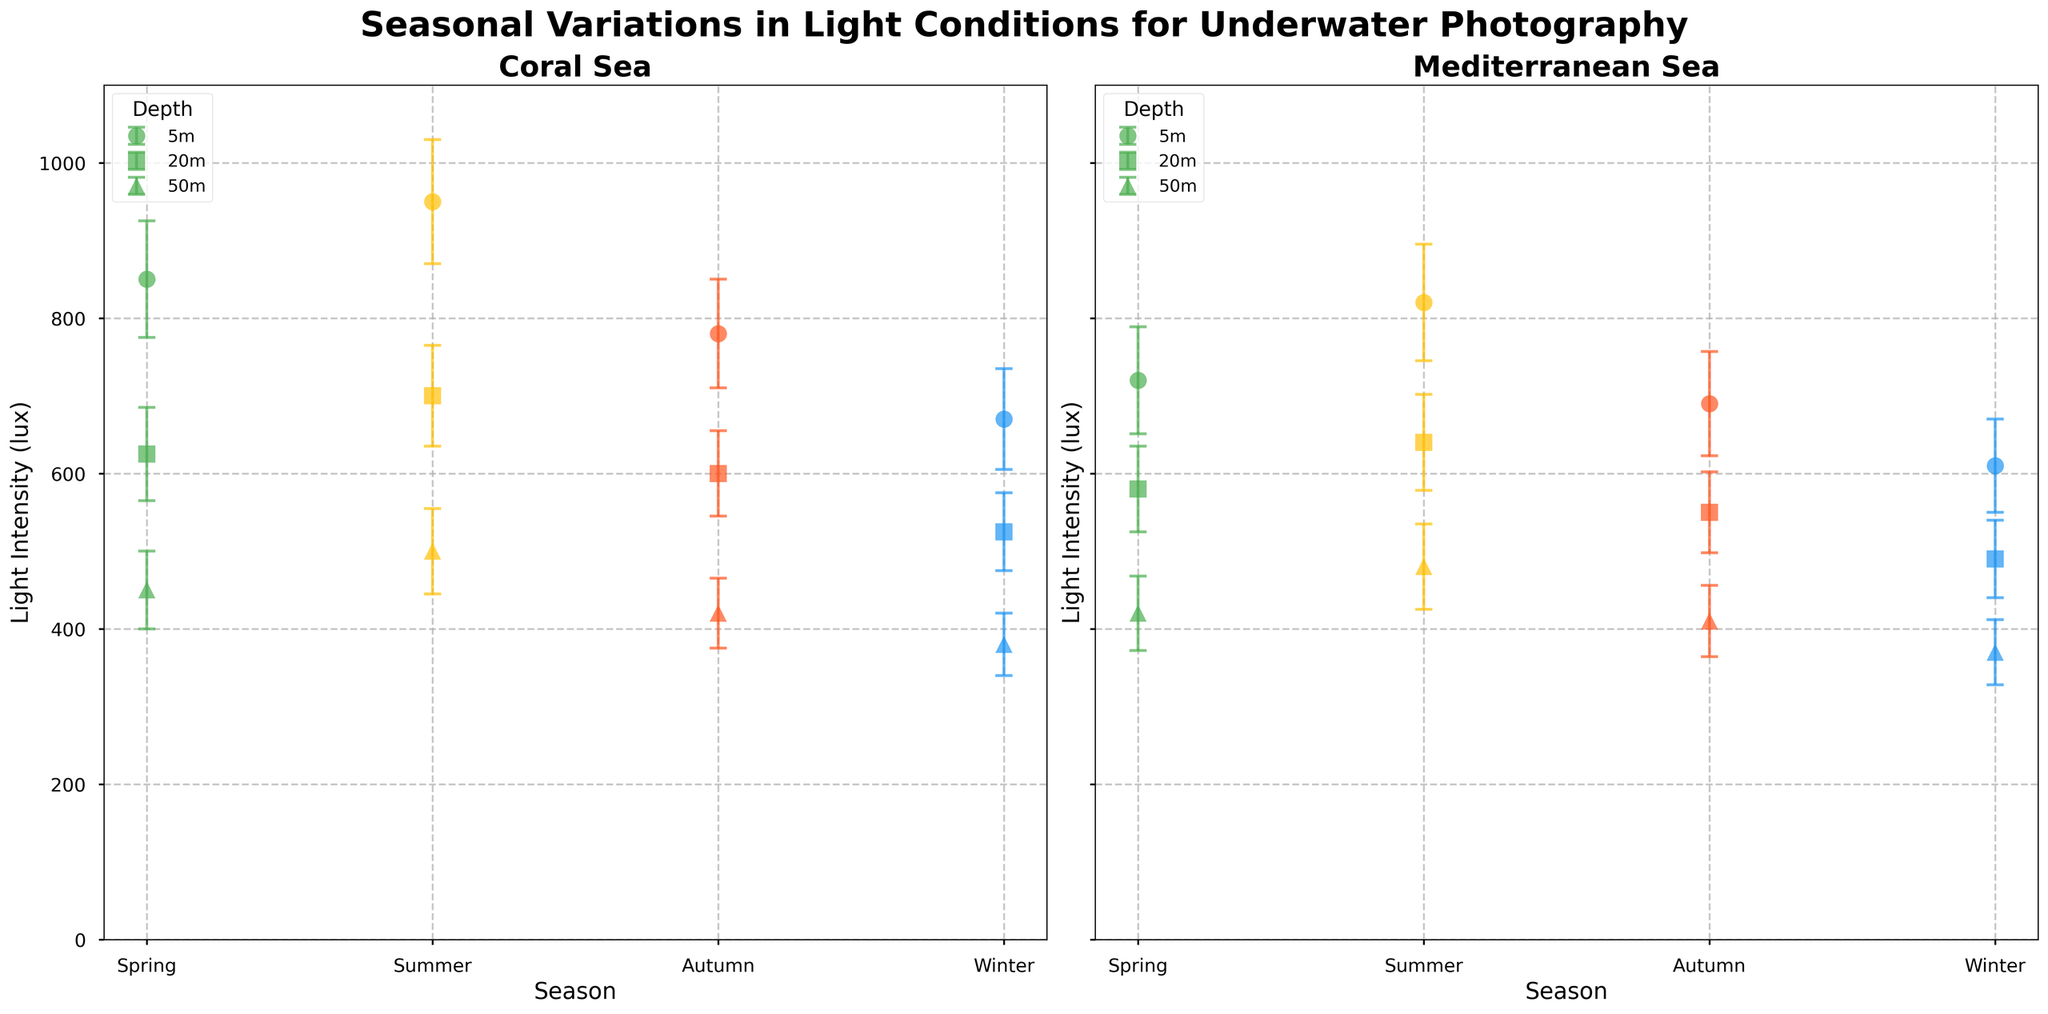What is the title of the figure? The title is displayed prominently at the top of the figure.
Answer: Seasonal Variations in Light Conditions for Underwater Photography Which season has the highest average light intensity at 5 meters depth in the Coral Sea? From the subplot for the Coral Sea, observe the markers at 5 meters depth across seasons. The yellow marker (Summer) is the highest.
Answer: Summer How does the average light intensity at 20 meters in Autumn compare between the Coral Sea and the Mediterranean Sea? Compare the height of markers at 20 meters depth for Autumn in both subplots. The Coral Sea shows higher intensity than the Mediterranean.
Answer: Coral Sea is higher What is the depth with the lowest average light intensity in both locations during Winter? Look at the Winter season in both subplots and identify which depth (5m, 20m, 50m) has the lowest marker. The 50 meters depth shows the lowest intensity in both locations.
Answer: 50 meters How does the light intensity variability (error bars) in Summer at 5 meters depth compare between the two locations? Compare the length of the error bars for the Summer season at 5 meters depth in both subplots. The Coral Sea has longer error bars than the Mediterranean Sea.
Answer: Coral Sea has higher variability What is the difference in average light intensity at 20 meters depth between Spring and Summer in the Coral Sea? Look at the markers for 20 meters depth in the Coral Sea subplot. Subtract the Spring value (625 lux) from the Summer value (700 lux).
Answer: 75 lux Which season and depth combination has the smallest standard deviation in the Mediterranean Sea? Observe the error bars in the Mediterranean subplot to find the smallest. The Winter season at 50 meters depth has the shortest error bar.
Answer: Winter at 50 meters Is there any season where the average light intensity at 5 meters depth in the Mediterranean Sea is higher than in the Coral Sea? Compare the average light intensity for 5 meters depth across all seasons between the two subplots. None of the seasons show a higher value in the Mediterranean Sea.
Answer: No What is the general trend in average light intensity with increasing depth in the Coral Sea during Summer? Observe the markers for Summer in the Coral Sea subplot. As the depth increases, the light intensity decreases.
Answer: Decreasing trend 